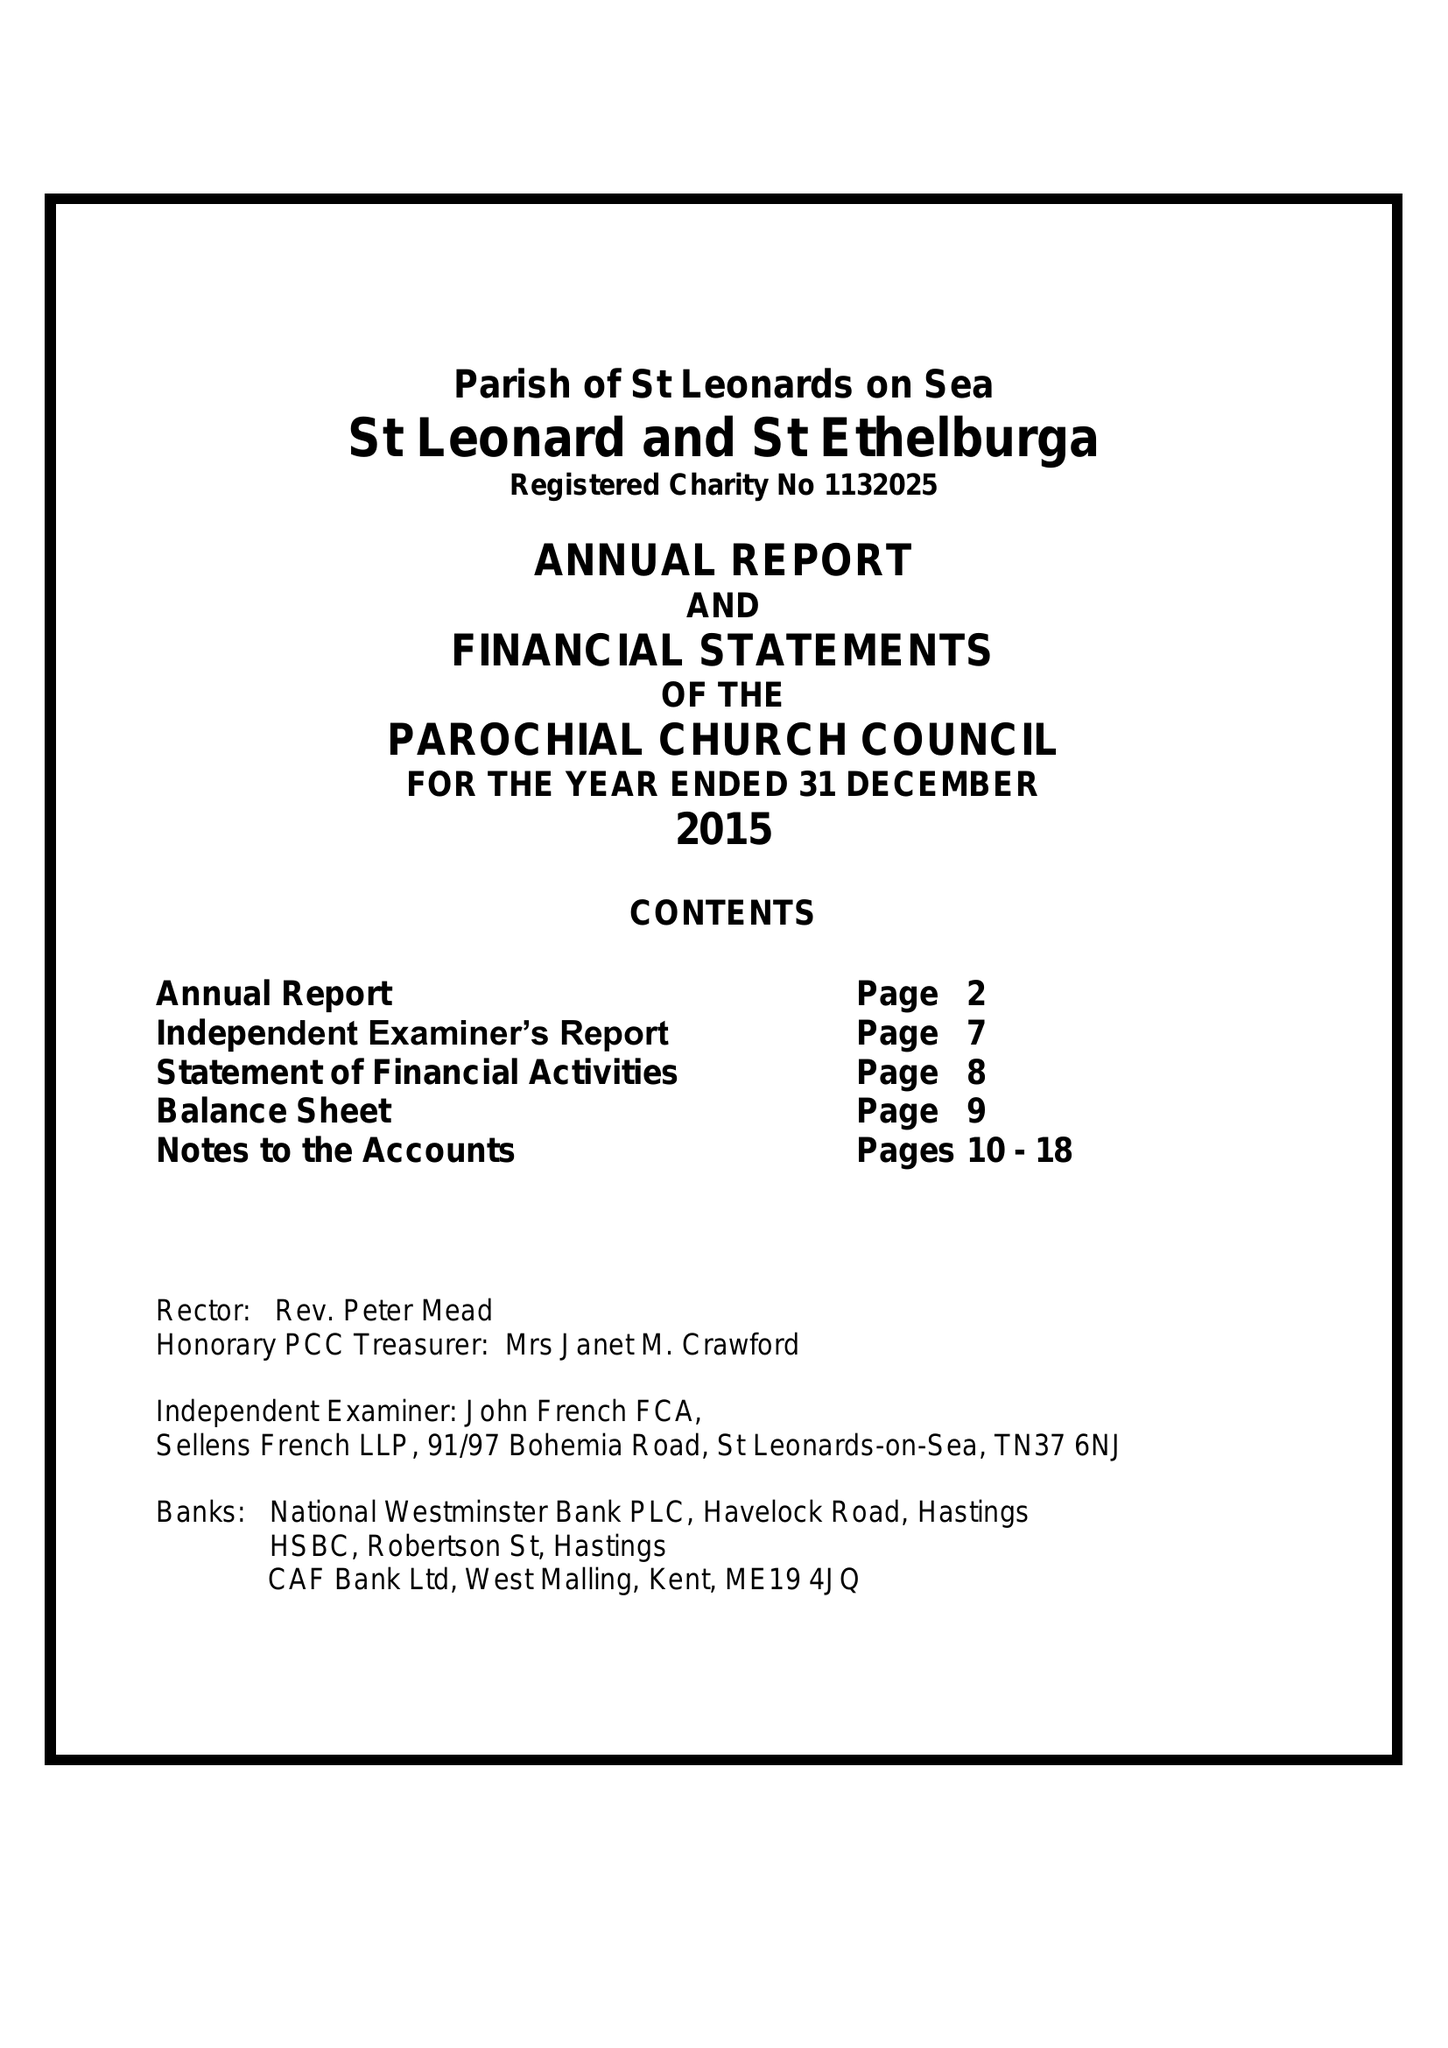What is the value for the charity_name?
Answer the question using a single word or phrase. The Parochial Church Council Of The Ecclesiastical Parish Of St Leonards On Sea, St Leonard and St Ethelburga 